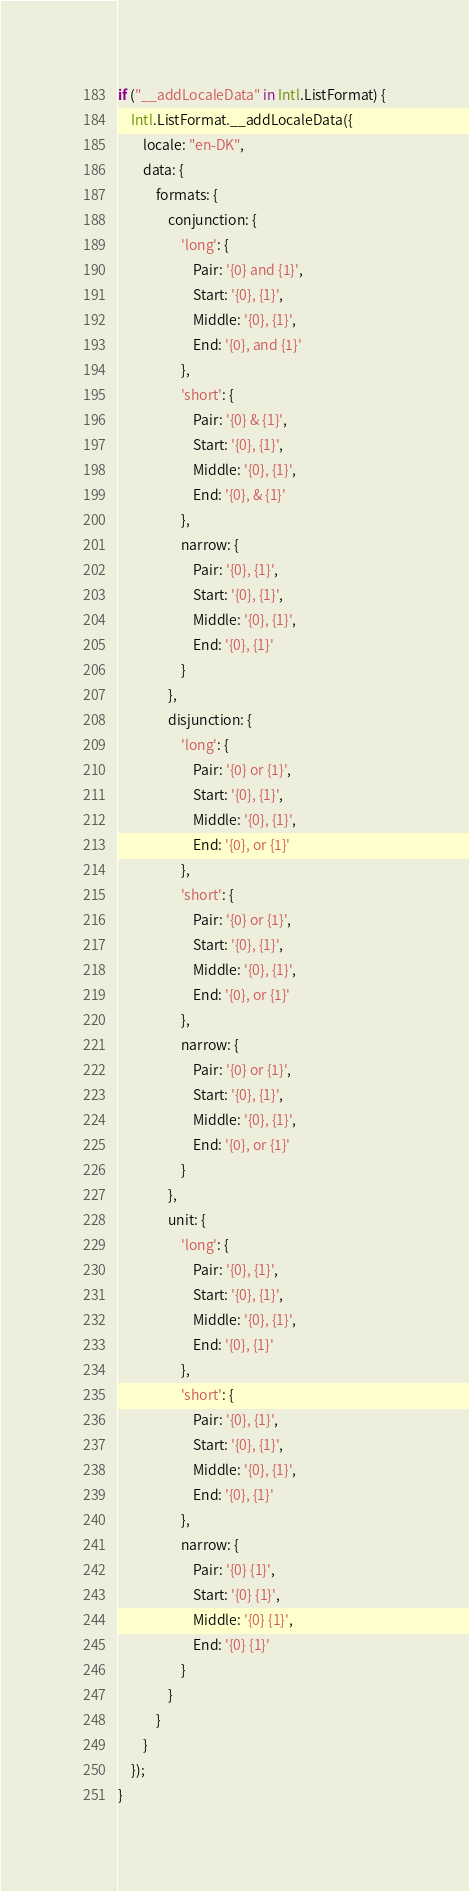Convert code to text. <code><loc_0><loc_0><loc_500><loc_500><_JavaScript_>if ("__addLocaleData" in Intl.ListFormat) {
    Intl.ListFormat.__addLocaleData({
        locale: "en-DK",
        data: {
            formats: {
                conjunction: {
                    'long': {
                        Pair: '{0} and {1}',
                        Start: '{0}, {1}',
                        Middle: '{0}, {1}',
                        End: '{0}, and {1}'
                    },
                    'short': {
                        Pair: '{0} & {1}',
                        Start: '{0}, {1}',
                        Middle: '{0}, {1}',
                        End: '{0}, & {1}'
                    },
                    narrow: {
                        Pair: '{0}, {1}',
                        Start: '{0}, {1}',
                        Middle: '{0}, {1}',
                        End: '{0}, {1}'
                    }
                },
                disjunction: {
                    'long': {
                        Pair: '{0} or {1}',
                        Start: '{0}, {1}',
                        Middle: '{0}, {1}',
                        End: '{0}, or {1}'
                    },
                    'short': {
                        Pair: '{0} or {1}',
                        Start: '{0}, {1}',
                        Middle: '{0}, {1}',
                        End: '{0}, or {1}'
                    },
                    narrow: {
                        Pair: '{0} or {1}',
                        Start: '{0}, {1}',
                        Middle: '{0}, {1}',
                        End: '{0}, or {1}'
                    }
                },
                unit: {
                    'long': {
                        Pair: '{0}, {1}',
                        Start: '{0}, {1}',
                        Middle: '{0}, {1}',
                        End: '{0}, {1}'
                    },
                    'short': {
                        Pair: '{0}, {1}',
                        Start: '{0}, {1}',
                        Middle: '{0}, {1}',
                        End: '{0}, {1}'
                    },
                    narrow: {
                        Pair: '{0} {1}',
                        Start: '{0} {1}',
                        Middle: '{0} {1}',
                        End: '{0} {1}'
                    }
                }
            }
        }
    });
}
</code> 